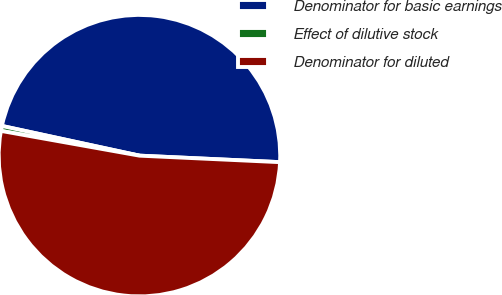Convert chart. <chart><loc_0><loc_0><loc_500><loc_500><pie_chart><fcel>Denominator for basic earnings<fcel>Effect of dilutive stock<fcel>Denominator for diluted<nl><fcel>47.35%<fcel>0.57%<fcel>52.08%<nl></chart> 